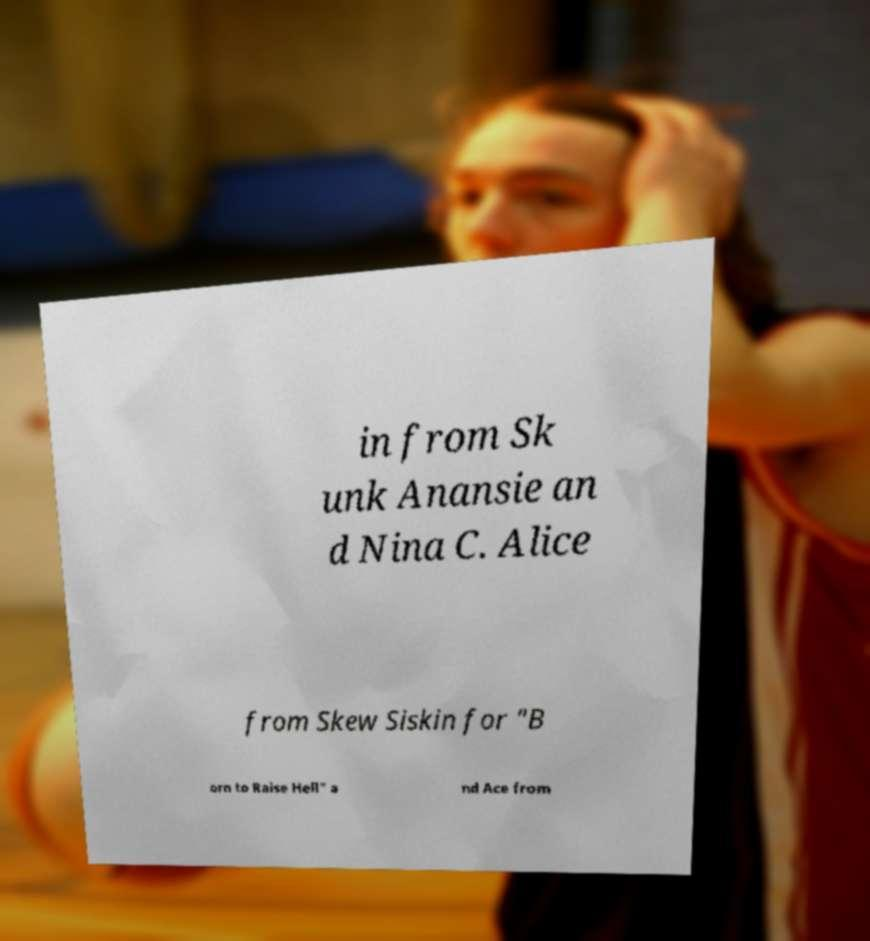I need the written content from this picture converted into text. Can you do that? in from Sk unk Anansie an d Nina C. Alice from Skew Siskin for "B orn to Raise Hell" a nd Ace from 